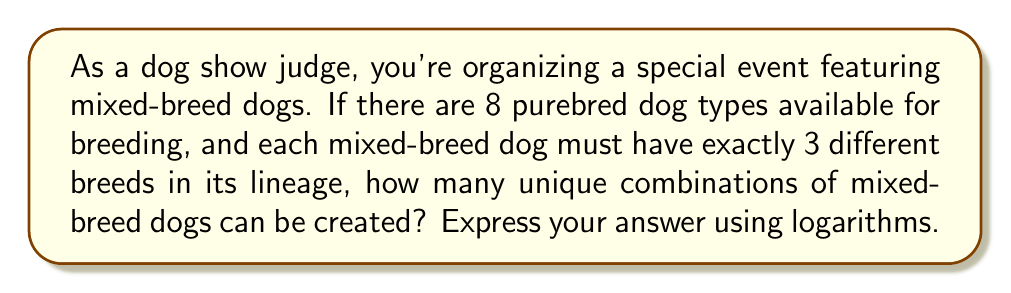Help me with this question. Let's approach this step-by-step:

1) First, we need to calculate the number of ways to choose 3 breeds from 8 available breeds. This is a combination problem, denoted as $C(8,3)$ or $\binom{8}{3}$.

2) The formula for this combination is:

   $$\binom{8}{3} = \frac{8!}{3!(8-3)!} = \frac{8!}{3!5!}$$

3) Expanding this:
   
   $$\frac{8 \cdot 7 \cdot 6 \cdot 5!}{(3 \cdot 2 \cdot 1) \cdot 5!} = \frac{336}{6} = 56$$

4) So, there are 56 unique combinations of mixed-breed dogs.

5) To express this using logarithms, we can use the property that for any number $x$:

   $$x = 10^{\log_{10}(x)}$$

6) Therefore, our answer can be expressed as:

   $$56 = 10^{\log_{10}(56)}$$

7) Using a calculator or logarithm table, we can find that:

   $$\log_{10}(56) \approx 1.7481880270062005$$

Thus, the number of unique combinations can be expressed as:

$$10^{1.7481880270062005}$$
Answer: $10^{\log_{10}(56)}$ 